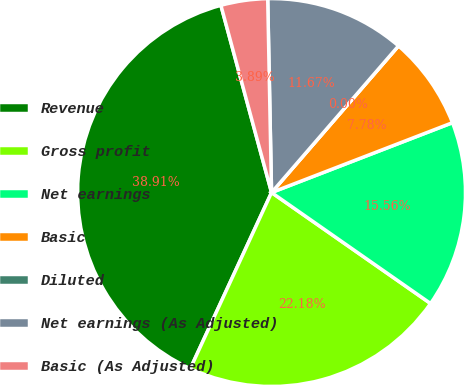<chart> <loc_0><loc_0><loc_500><loc_500><pie_chart><fcel>Revenue<fcel>Gross profit<fcel>Net earnings<fcel>Basic<fcel>Diluted<fcel>Net earnings (As Adjusted)<fcel>Basic (As Adjusted)<nl><fcel>38.91%<fcel>22.18%<fcel>15.56%<fcel>7.78%<fcel>0.0%<fcel>11.67%<fcel>3.89%<nl></chart> 